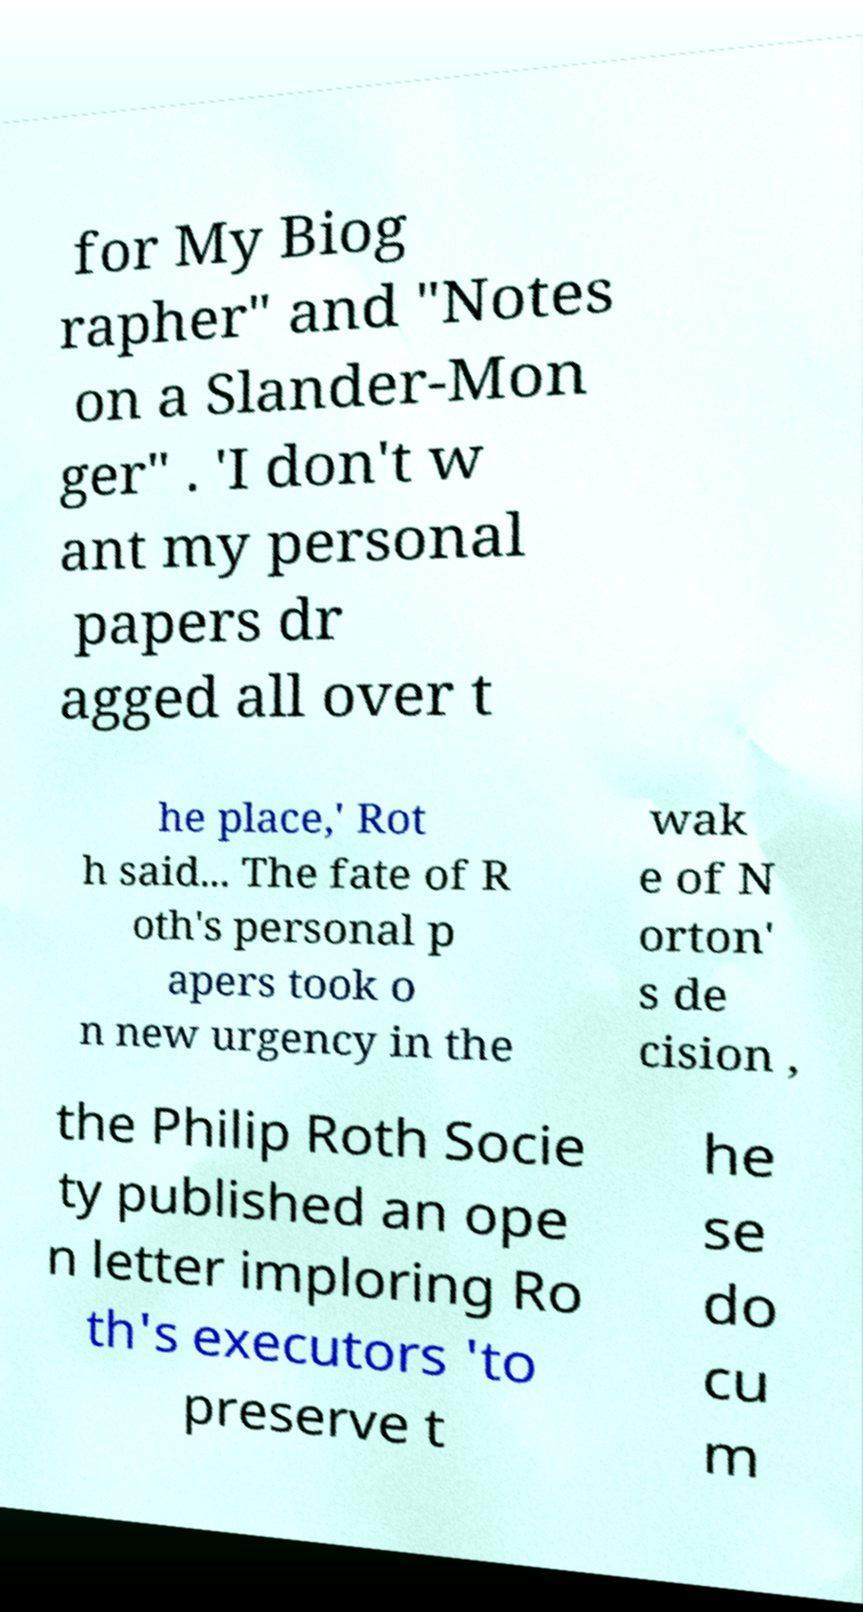Can you accurately transcribe the text from the provided image for me? for My Biog rapher" and "Notes on a Slander-Mon ger" . 'I don't w ant my personal papers dr agged all over t he place,' Rot h said... The fate of R oth's personal p apers took o n new urgency in the wak e of N orton' s de cision , the Philip Roth Socie ty published an ope n letter imploring Ro th's executors 'to preserve t he se do cu m 